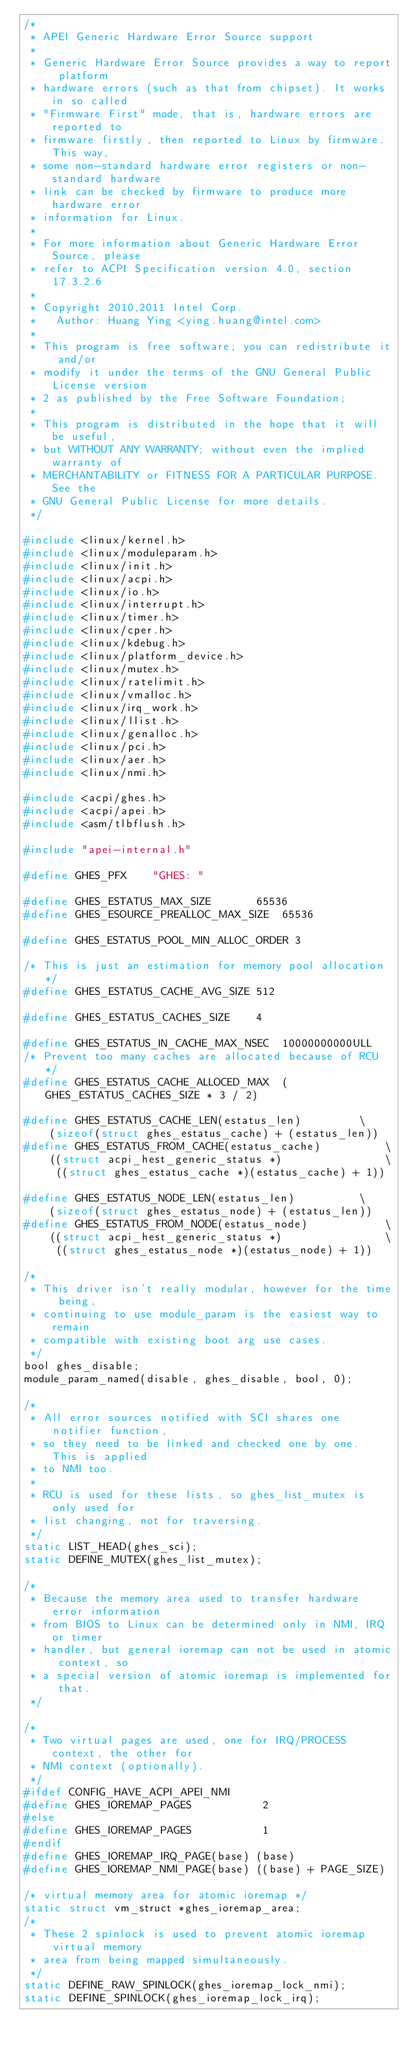Convert code to text. <code><loc_0><loc_0><loc_500><loc_500><_C_>/*
 * APEI Generic Hardware Error Source support
 *
 * Generic Hardware Error Source provides a way to report platform
 * hardware errors (such as that from chipset). It works in so called
 * "Firmware First" mode, that is, hardware errors are reported to
 * firmware firstly, then reported to Linux by firmware. This way,
 * some non-standard hardware error registers or non-standard hardware
 * link can be checked by firmware to produce more hardware error
 * information for Linux.
 *
 * For more information about Generic Hardware Error Source, please
 * refer to ACPI Specification version 4.0, section 17.3.2.6
 *
 * Copyright 2010,2011 Intel Corp.
 *   Author: Huang Ying <ying.huang@intel.com>
 *
 * This program is free software; you can redistribute it and/or
 * modify it under the terms of the GNU General Public License version
 * 2 as published by the Free Software Foundation;
 *
 * This program is distributed in the hope that it will be useful,
 * but WITHOUT ANY WARRANTY; without even the implied warranty of
 * MERCHANTABILITY or FITNESS FOR A PARTICULAR PURPOSE.  See the
 * GNU General Public License for more details.
 */

#include <linux/kernel.h>
#include <linux/moduleparam.h>
#include <linux/init.h>
#include <linux/acpi.h>
#include <linux/io.h>
#include <linux/interrupt.h>
#include <linux/timer.h>
#include <linux/cper.h>
#include <linux/kdebug.h>
#include <linux/platform_device.h>
#include <linux/mutex.h>
#include <linux/ratelimit.h>
#include <linux/vmalloc.h>
#include <linux/irq_work.h>
#include <linux/llist.h>
#include <linux/genalloc.h>
#include <linux/pci.h>
#include <linux/aer.h>
#include <linux/nmi.h>

#include <acpi/ghes.h>
#include <acpi/apei.h>
#include <asm/tlbflush.h>

#include "apei-internal.h"

#define GHES_PFX	"GHES: "

#define GHES_ESTATUS_MAX_SIZE		65536
#define GHES_ESOURCE_PREALLOC_MAX_SIZE	65536

#define GHES_ESTATUS_POOL_MIN_ALLOC_ORDER 3

/* This is just an estimation for memory pool allocation */
#define GHES_ESTATUS_CACHE_AVG_SIZE	512

#define GHES_ESTATUS_CACHES_SIZE	4

#define GHES_ESTATUS_IN_CACHE_MAX_NSEC	10000000000ULL
/* Prevent too many caches are allocated because of RCU */
#define GHES_ESTATUS_CACHE_ALLOCED_MAX	(GHES_ESTATUS_CACHES_SIZE * 3 / 2)

#define GHES_ESTATUS_CACHE_LEN(estatus_len)			\
	(sizeof(struct ghes_estatus_cache) + (estatus_len))
#define GHES_ESTATUS_FROM_CACHE(estatus_cache)			\
	((struct acpi_hest_generic_status *)				\
	 ((struct ghes_estatus_cache *)(estatus_cache) + 1))

#define GHES_ESTATUS_NODE_LEN(estatus_len)			\
	(sizeof(struct ghes_estatus_node) + (estatus_len))
#define GHES_ESTATUS_FROM_NODE(estatus_node)			\
	((struct acpi_hest_generic_status *)				\
	 ((struct ghes_estatus_node *)(estatus_node) + 1))

/*
 * This driver isn't really modular, however for the time being,
 * continuing to use module_param is the easiest way to remain
 * compatible with existing boot arg use cases.
 */
bool ghes_disable;
module_param_named(disable, ghes_disable, bool, 0);

/*
 * All error sources notified with SCI shares one notifier function,
 * so they need to be linked and checked one by one.  This is applied
 * to NMI too.
 *
 * RCU is used for these lists, so ghes_list_mutex is only used for
 * list changing, not for traversing.
 */
static LIST_HEAD(ghes_sci);
static DEFINE_MUTEX(ghes_list_mutex);

/*
 * Because the memory area used to transfer hardware error information
 * from BIOS to Linux can be determined only in NMI, IRQ or timer
 * handler, but general ioremap can not be used in atomic context, so
 * a special version of atomic ioremap is implemented for that.
 */

/*
 * Two virtual pages are used, one for IRQ/PROCESS context, the other for
 * NMI context (optionally).
 */
#ifdef CONFIG_HAVE_ACPI_APEI_NMI
#define GHES_IOREMAP_PAGES           2
#else
#define GHES_IOREMAP_PAGES           1
#endif
#define GHES_IOREMAP_IRQ_PAGE(base)	(base)
#define GHES_IOREMAP_NMI_PAGE(base)	((base) + PAGE_SIZE)

/* virtual memory area for atomic ioremap */
static struct vm_struct *ghes_ioremap_area;
/*
 * These 2 spinlock is used to prevent atomic ioremap virtual memory
 * area from being mapped simultaneously.
 */
static DEFINE_RAW_SPINLOCK(ghes_ioremap_lock_nmi);
static DEFINE_SPINLOCK(ghes_ioremap_lock_irq);
</code> 